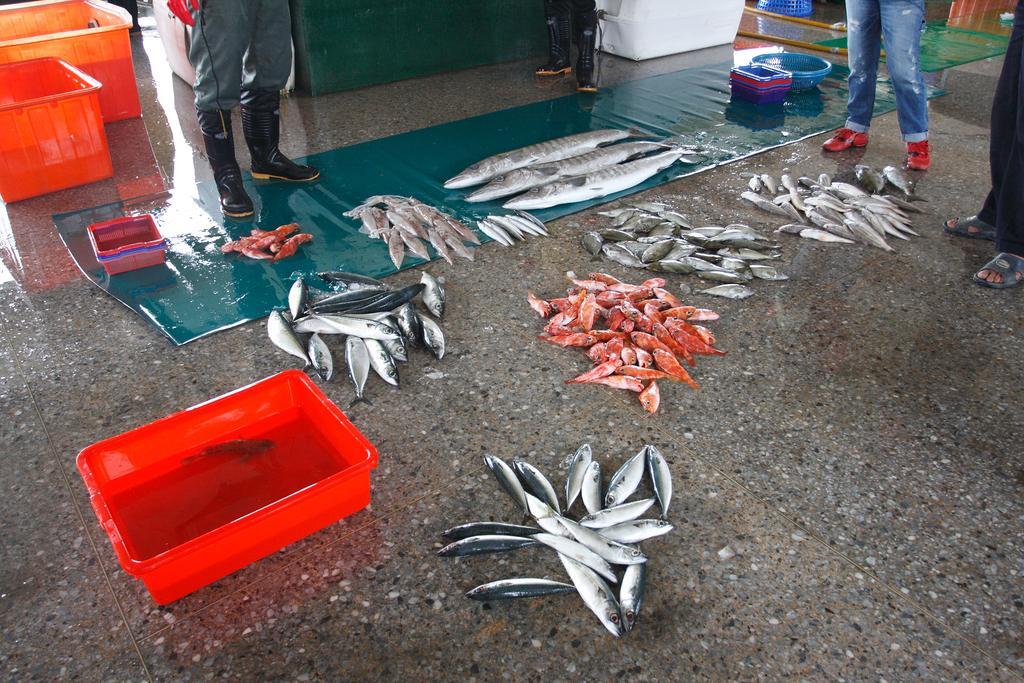How would you summarize this image in a sentence or two? In this picture I can see different types of fishes on the floor and on the mat, there are plastic containers, plastic bowls, there are group of people standing, and in the background there are some items. 